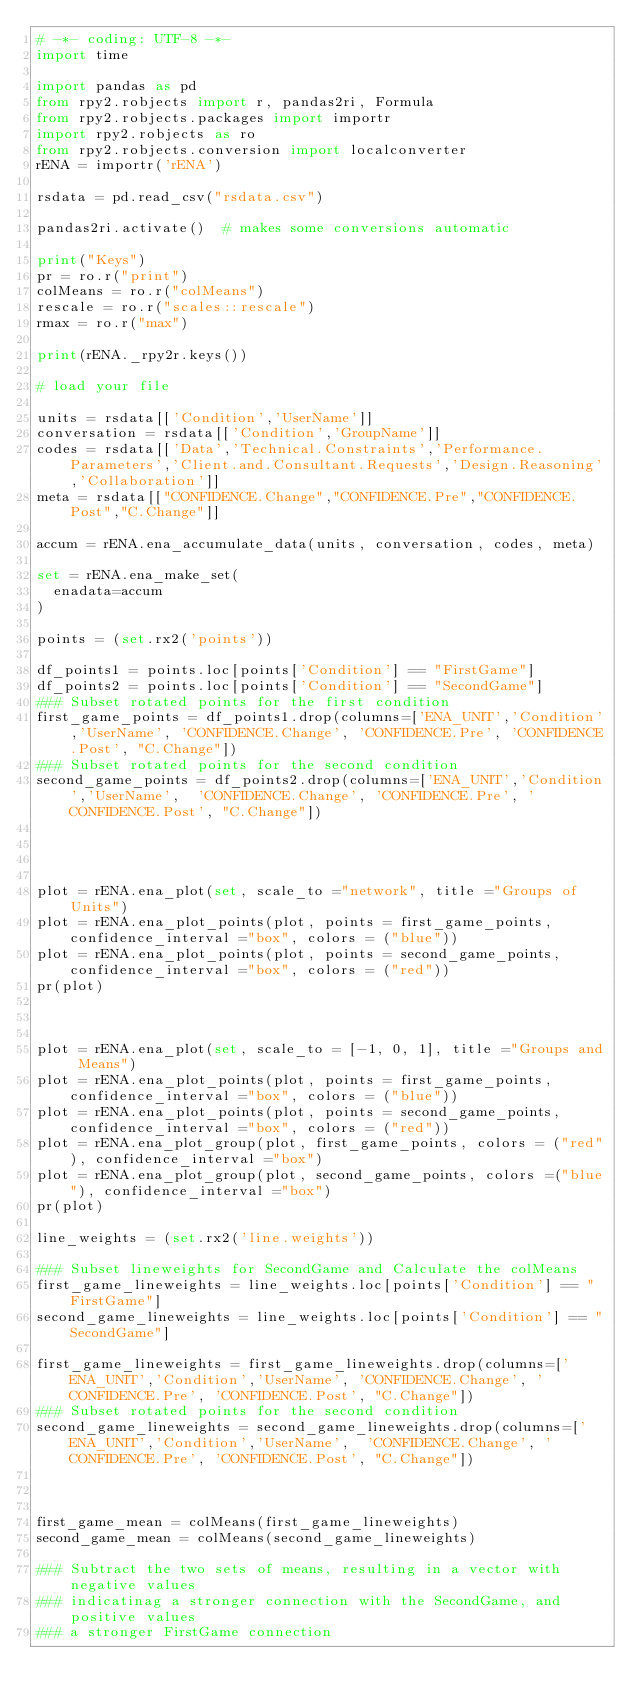<code> <loc_0><loc_0><loc_500><loc_500><_Python_># -*- coding: UTF-8 -*-
import time

import pandas as pd
from rpy2.robjects import r, pandas2ri, Formula
from rpy2.robjects.packages import importr
import rpy2.robjects as ro
from rpy2.robjects.conversion import localconverter
rENA = importr('rENA')

rsdata = pd.read_csv("rsdata.csv")

pandas2ri.activate()  # makes some conversions automatic

print("Keys")
pr = ro.r("print")
colMeans = ro.r("colMeans")
rescale = ro.r("scales::rescale")
rmax = ro.r("max")

print(rENA._rpy2r.keys())

# load your file

units = rsdata[['Condition','UserName']]
conversation = rsdata[['Condition','GroupName']]
codes = rsdata[['Data','Technical.Constraints','Performance.Parameters','Client.and.Consultant.Requests','Design.Reasoning','Collaboration']]
meta = rsdata[["CONFIDENCE.Change","CONFIDENCE.Pre","CONFIDENCE.Post","C.Change"]]

accum = rENA.ena_accumulate_data(units, conversation, codes, meta)

set = rENA.ena_make_set(
  enadata=accum
)

points = (set.rx2('points'))

df_points1 = points.loc[points['Condition'] == "FirstGame"]
df_points2 = points.loc[points['Condition'] == "SecondGame"]
### Subset rotated points for the first condition
first_game_points = df_points1.drop(columns=['ENA_UNIT','Condition','UserName', 'CONFIDENCE.Change', 'CONFIDENCE.Pre', 'CONFIDENCE.Post', "C.Change"])
### Subset rotated points for the second condition
second_game_points = df_points2.drop(columns=['ENA_UNIT','Condition','UserName',  'CONFIDENCE.Change', 'CONFIDENCE.Pre', 'CONFIDENCE.Post', "C.Change"])




plot = rENA.ena_plot(set, scale_to ="network", title ="Groups of Units")
plot = rENA.ena_plot_points(plot, points = first_game_points, confidence_interval ="box", colors = ("blue"))
plot = rENA.ena_plot_points(plot, points = second_game_points, confidence_interval ="box", colors = ("red"))
pr(plot)



plot = rENA.ena_plot(set, scale_to = [-1, 0, 1], title ="Groups and Means")
plot = rENA.ena_plot_points(plot, points = first_game_points, confidence_interval ="box", colors = ("blue"))
plot = rENA.ena_plot_points(plot, points = second_game_points, confidence_interval ="box", colors = ("red"))
plot = rENA.ena_plot_group(plot, first_game_points, colors = ("red"), confidence_interval ="box")
plot = rENA.ena_plot_group(plot, second_game_points, colors =("blue"), confidence_interval ="box")
pr(plot)

line_weights = (set.rx2('line.weights'))

### Subset lineweights for SecondGame and Calculate the colMeans
first_game_lineweights = line_weights.loc[points['Condition'] == "FirstGame"]
second_game_lineweights = line_weights.loc[points['Condition'] == "SecondGame"]

first_game_lineweights = first_game_lineweights.drop(columns=['ENA_UNIT','Condition','UserName', 'CONFIDENCE.Change', 'CONFIDENCE.Pre', 'CONFIDENCE.Post', "C.Change"])
### Subset rotated points for the second condition
second_game_lineweights = second_game_lineweights.drop(columns=['ENA_UNIT','Condition','UserName',  'CONFIDENCE.Change', 'CONFIDENCE.Pre', 'CONFIDENCE.Post', "C.Change"])



first_game_mean = colMeans(first_game_lineweights)
second_game_mean = colMeans(second_game_lineweights)

### Subtract the two sets of means, resulting in a vector with negative values
### indicatinag a stronger connection with the SecondGame, and positive values
### a stronger FirstGame connection</code> 